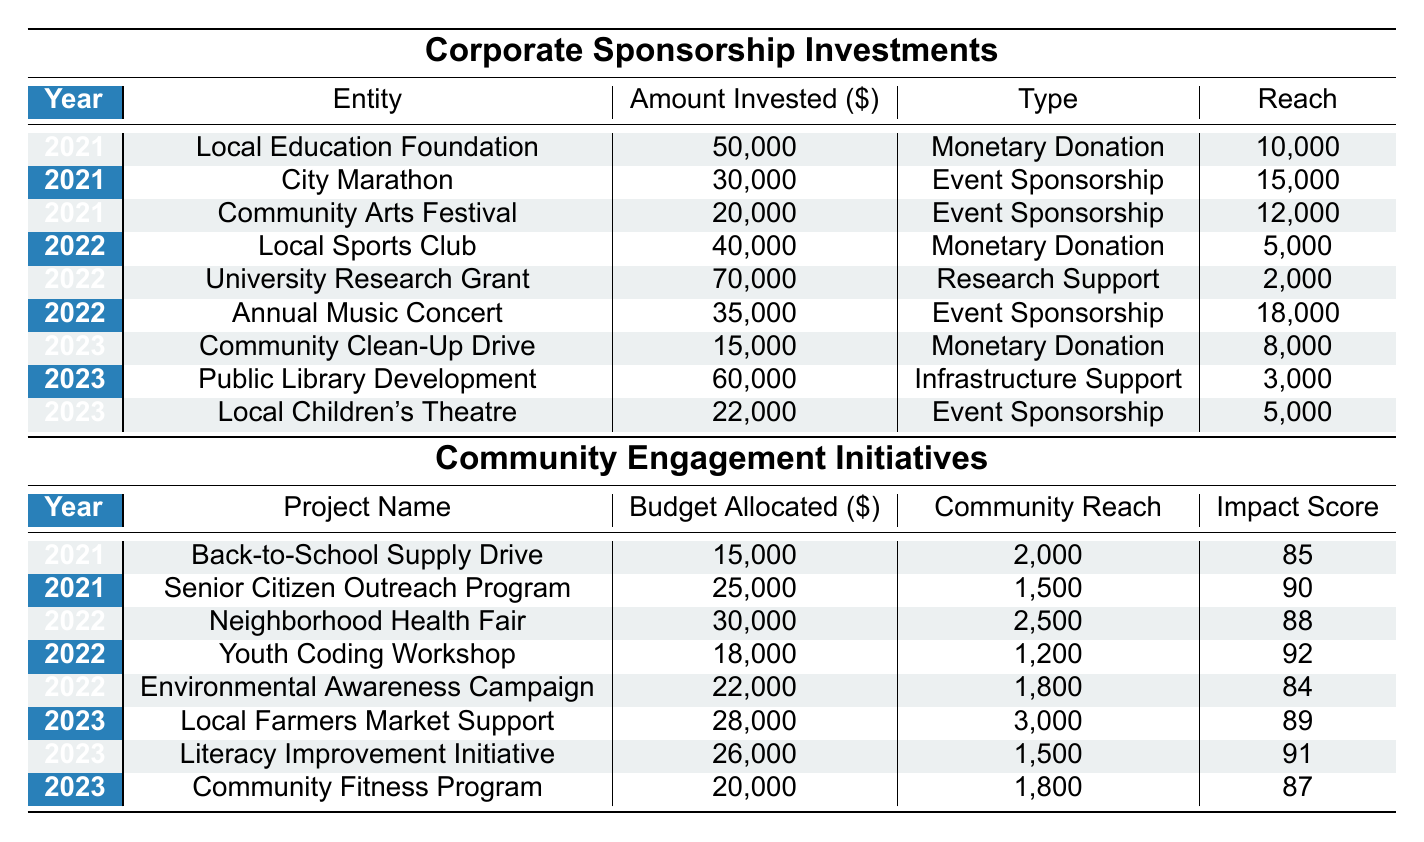What was the total amount invested in Corporate Sponsorships in 2021? From the table, we can look at the "Amount Invested" column for the year 2021. The values are 50000, 30000, and 20000. Adding these amounts gives: 50000 + 30000 + 20000 = 100000.
Answer: 100000 Which community engagement initiative had the highest impact score in 2022? In 2022, the initiatives and their impact scores are: Neighborhood Health Fair (88), Youth Coding Workshop (92), and Environmental Awareness Campaign (84). The highest score is 92 from the Youth Coding Workshop.
Answer: Youth Coding Workshop Did the Local Sports Club receive a monetary donation in 2022? According to the table, the Local Sports Club does have a monetary donation listed under the Corporate Sponsorship Investments for 2022. Therefore, the answer is yes.
Answer: Yes What is the average budget allocated for community engagement initiatives in 2023? For 2023, the budgets allocated are: 28000, 26000, and 20000. First, we sum these amounts: 28000 + 26000 + 20000 = 74000. There are 3 initiatives, so we divide: 74000 / 3 = 24666.67. The average budget is approximately 24667.
Answer: 24667 How much was invested in event sponsorships in 2023? Looking at the Corporate Sponsorship Investments for 2023, the event sponsorships are Local Children's Theatre for 22000 and Community Clean-Up Drive for 15000. Summing these gives: 22000 + 15000 = 37000.
Answer: 37000 Was the budget allocated for the Senior Citizen Outreach Program higher than the budget for the Youth Coding Workshop? The Senior Citizen Outreach Program has a budget of 25000 while the Youth Coding Workshop has 18000. Since 25000 is greater than 18000, the answer is yes.
Answer: Yes What was the total reach of all community engagement initiatives in 2021? The community engagement initiatives in 2021 had the following reaches: Back-to-School Supply Drive (2000) and Senior Citizen Outreach Program (1500). Adding these values: 2000 + 1500 = 3500 gives us the total reach for 2021.
Answer: 3500 Which entity received the lowest amount invested in Corporate Sponsorships in 2022? In 2022, the investments were 40000 for Local Sports Club, 70000 for University Research Grant, and 35000 for Annual Music Concert. The lowest amount is 40000 received by the Local Sports Club.
Answer: Local Sports Club What was the impact score of the Literacy Improvement Initiative in 2023? The Literacy Improvement Initiative for 2023 has an impact score listed in the table as 91.
Answer: 91 